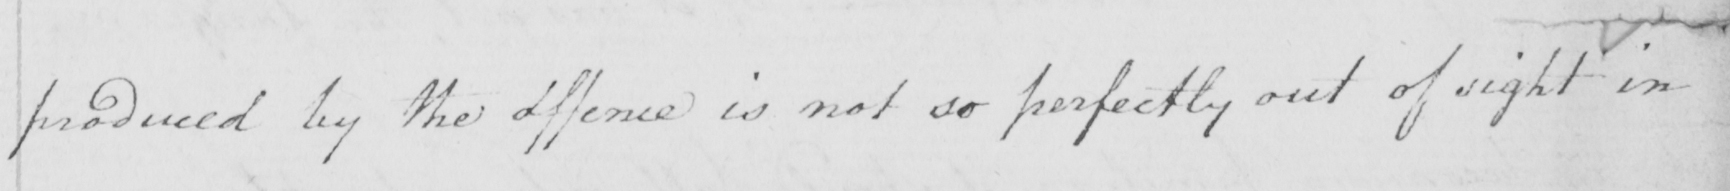Please provide the text content of this handwritten line. produced by the offence is not so perfectly out of sight in 